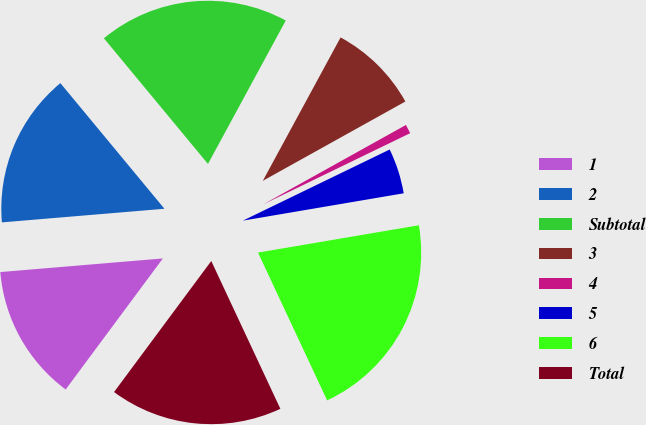Convert chart. <chart><loc_0><loc_0><loc_500><loc_500><pie_chart><fcel>1<fcel>2<fcel>Subtotal<fcel>3<fcel>4<fcel>5<fcel>6<fcel>Total<nl><fcel>13.51%<fcel>15.32%<fcel>18.92%<fcel>9.01%<fcel>0.9%<fcel>4.5%<fcel>20.72%<fcel>17.12%<nl></chart> 